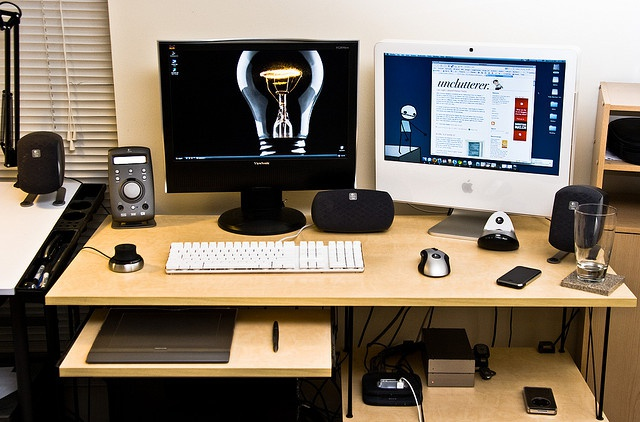Describe the objects in this image and their specific colors. I can see tv in tan, lightgray, navy, black, and lightblue tones, tv in tan, black, white, and gray tones, keyboard in tan, white, and darkgray tones, cup in tan, black, gray, and maroon tones, and mouse in tan, lightgray, black, darkgray, and gray tones in this image. 